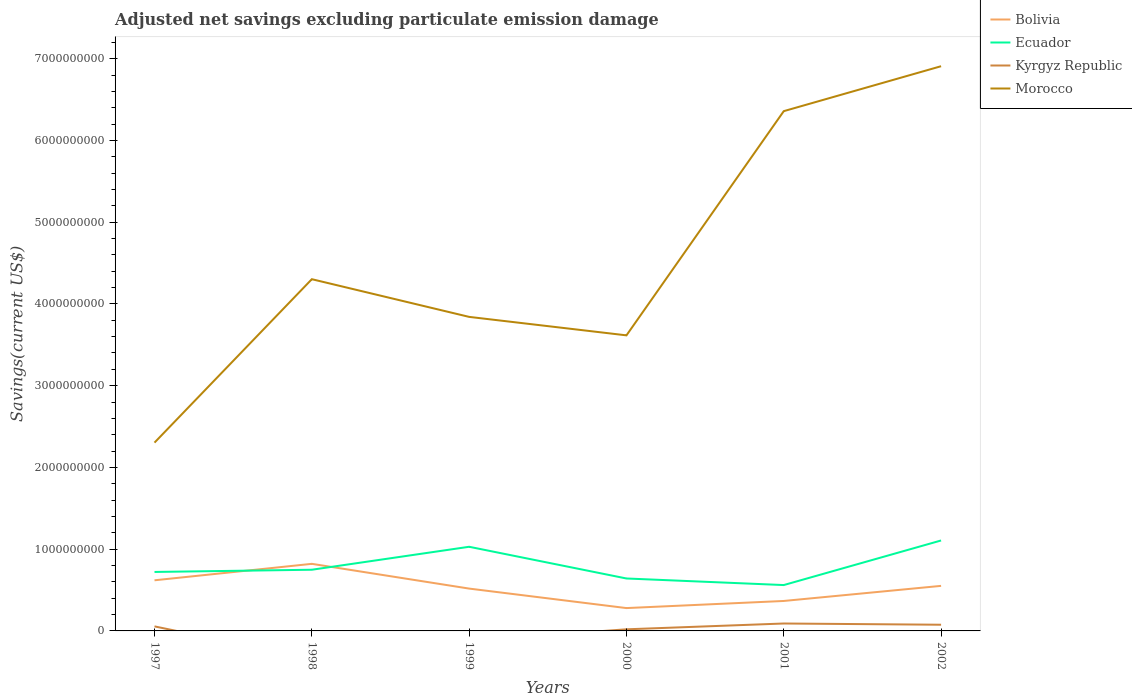Is the number of lines equal to the number of legend labels?
Your answer should be compact. No. Across all years, what is the maximum adjusted net savings in Kyrgyz Republic?
Offer a very short reply. 0. What is the total adjusted net savings in Ecuador in the graph?
Provide a short and direct response. -5.45e+08. What is the difference between the highest and the second highest adjusted net savings in Bolivia?
Offer a terse response. 5.41e+08. How many lines are there?
Provide a succinct answer. 4. How many years are there in the graph?
Provide a short and direct response. 6. What is the difference between two consecutive major ticks on the Y-axis?
Offer a terse response. 1.00e+09. What is the title of the graph?
Your response must be concise. Adjusted net savings excluding particulate emission damage. What is the label or title of the Y-axis?
Give a very brief answer. Savings(current US$). What is the Savings(current US$) in Bolivia in 1997?
Provide a succinct answer. 6.19e+08. What is the Savings(current US$) in Ecuador in 1997?
Your answer should be very brief. 7.21e+08. What is the Savings(current US$) of Kyrgyz Republic in 1997?
Keep it short and to the point. 5.55e+07. What is the Savings(current US$) in Morocco in 1997?
Give a very brief answer. 2.30e+09. What is the Savings(current US$) of Bolivia in 1998?
Your response must be concise. 8.21e+08. What is the Savings(current US$) in Ecuador in 1998?
Give a very brief answer. 7.48e+08. What is the Savings(current US$) of Morocco in 1998?
Provide a short and direct response. 4.30e+09. What is the Savings(current US$) of Bolivia in 1999?
Ensure brevity in your answer.  5.18e+08. What is the Savings(current US$) in Ecuador in 1999?
Ensure brevity in your answer.  1.03e+09. What is the Savings(current US$) of Morocco in 1999?
Your answer should be very brief. 3.84e+09. What is the Savings(current US$) in Bolivia in 2000?
Your answer should be compact. 2.79e+08. What is the Savings(current US$) in Ecuador in 2000?
Make the answer very short. 6.41e+08. What is the Savings(current US$) of Kyrgyz Republic in 2000?
Offer a terse response. 1.97e+07. What is the Savings(current US$) of Morocco in 2000?
Make the answer very short. 3.62e+09. What is the Savings(current US$) in Bolivia in 2001?
Give a very brief answer. 3.66e+08. What is the Savings(current US$) of Ecuador in 2001?
Provide a short and direct response. 5.61e+08. What is the Savings(current US$) in Kyrgyz Republic in 2001?
Provide a succinct answer. 9.07e+07. What is the Savings(current US$) of Morocco in 2001?
Make the answer very short. 6.36e+09. What is the Savings(current US$) in Bolivia in 2002?
Offer a very short reply. 5.51e+08. What is the Savings(current US$) in Ecuador in 2002?
Offer a very short reply. 1.11e+09. What is the Savings(current US$) in Kyrgyz Republic in 2002?
Give a very brief answer. 7.56e+07. What is the Savings(current US$) of Morocco in 2002?
Offer a terse response. 6.91e+09. Across all years, what is the maximum Savings(current US$) in Bolivia?
Your answer should be very brief. 8.21e+08. Across all years, what is the maximum Savings(current US$) of Ecuador?
Offer a very short reply. 1.11e+09. Across all years, what is the maximum Savings(current US$) in Kyrgyz Republic?
Offer a very short reply. 9.07e+07. Across all years, what is the maximum Savings(current US$) of Morocco?
Your response must be concise. 6.91e+09. Across all years, what is the minimum Savings(current US$) of Bolivia?
Your answer should be compact. 2.79e+08. Across all years, what is the minimum Savings(current US$) in Ecuador?
Offer a terse response. 5.61e+08. Across all years, what is the minimum Savings(current US$) in Morocco?
Provide a short and direct response. 2.30e+09. What is the total Savings(current US$) of Bolivia in the graph?
Your answer should be very brief. 3.15e+09. What is the total Savings(current US$) in Ecuador in the graph?
Provide a short and direct response. 4.81e+09. What is the total Savings(current US$) in Kyrgyz Republic in the graph?
Offer a terse response. 2.42e+08. What is the total Savings(current US$) of Morocco in the graph?
Ensure brevity in your answer.  2.73e+1. What is the difference between the Savings(current US$) in Bolivia in 1997 and that in 1998?
Offer a very short reply. -2.01e+08. What is the difference between the Savings(current US$) in Ecuador in 1997 and that in 1998?
Ensure brevity in your answer.  -2.72e+07. What is the difference between the Savings(current US$) of Morocco in 1997 and that in 1998?
Offer a terse response. -2.00e+09. What is the difference between the Savings(current US$) of Bolivia in 1997 and that in 1999?
Ensure brevity in your answer.  1.02e+08. What is the difference between the Savings(current US$) in Ecuador in 1997 and that in 1999?
Your response must be concise. -3.08e+08. What is the difference between the Savings(current US$) of Morocco in 1997 and that in 1999?
Provide a short and direct response. -1.54e+09. What is the difference between the Savings(current US$) in Bolivia in 1997 and that in 2000?
Offer a very short reply. 3.40e+08. What is the difference between the Savings(current US$) in Ecuador in 1997 and that in 2000?
Your answer should be compact. 7.98e+07. What is the difference between the Savings(current US$) of Kyrgyz Republic in 1997 and that in 2000?
Offer a terse response. 3.58e+07. What is the difference between the Savings(current US$) in Morocco in 1997 and that in 2000?
Your answer should be compact. -1.31e+09. What is the difference between the Savings(current US$) of Bolivia in 1997 and that in 2001?
Your response must be concise. 2.53e+08. What is the difference between the Savings(current US$) of Ecuador in 1997 and that in 2001?
Offer a very short reply. 1.60e+08. What is the difference between the Savings(current US$) of Kyrgyz Republic in 1997 and that in 2001?
Provide a succinct answer. -3.52e+07. What is the difference between the Savings(current US$) in Morocco in 1997 and that in 2001?
Offer a terse response. -4.05e+09. What is the difference between the Savings(current US$) in Bolivia in 1997 and that in 2002?
Your answer should be very brief. 6.83e+07. What is the difference between the Savings(current US$) of Ecuador in 1997 and that in 2002?
Ensure brevity in your answer.  -3.85e+08. What is the difference between the Savings(current US$) of Kyrgyz Republic in 1997 and that in 2002?
Your answer should be compact. -2.01e+07. What is the difference between the Savings(current US$) in Morocco in 1997 and that in 2002?
Your answer should be compact. -4.60e+09. What is the difference between the Savings(current US$) of Bolivia in 1998 and that in 1999?
Provide a short and direct response. 3.03e+08. What is the difference between the Savings(current US$) in Ecuador in 1998 and that in 1999?
Your answer should be compact. -2.81e+08. What is the difference between the Savings(current US$) in Morocco in 1998 and that in 1999?
Provide a succinct answer. 4.61e+08. What is the difference between the Savings(current US$) of Bolivia in 1998 and that in 2000?
Offer a terse response. 5.41e+08. What is the difference between the Savings(current US$) of Ecuador in 1998 and that in 2000?
Keep it short and to the point. 1.07e+08. What is the difference between the Savings(current US$) of Morocco in 1998 and that in 2000?
Give a very brief answer. 6.87e+08. What is the difference between the Savings(current US$) of Bolivia in 1998 and that in 2001?
Your answer should be very brief. 4.54e+08. What is the difference between the Savings(current US$) of Ecuador in 1998 and that in 2001?
Offer a terse response. 1.87e+08. What is the difference between the Savings(current US$) in Morocco in 1998 and that in 2001?
Offer a terse response. -2.06e+09. What is the difference between the Savings(current US$) in Bolivia in 1998 and that in 2002?
Keep it short and to the point. 2.70e+08. What is the difference between the Savings(current US$) in Ecuador in 1998 and that in 2002?
Your response must be concise. -3.58e+08. What is the difference between the Savings(current US$) of Morocco in 1998 and that in 2002?
Provide a succinct answer. -2.61e+09. What is the difference between the Savings(current US$) in Bolivia in 1999 and that in 2000?
Your response must be concise. 2.38e+08. What is the difference between the Savings(current US$) of Ecuador in 1999 and that in 2000?
Make the answer very short. 3.88e+08. What is the difference between the Savings(current US$) in Morocco in 1999 and that in 2000?
Keep it short and to the point. 2.26e+08. What is the difference between the Savings(current US$) of Bolivia in 1999 and that in 2001?
Provide a succinct answer. 1.51e+08. What is the difference between the Savings(current US$) of Ecuador in 1999 and that in 2001?
Your answer should be compact. 4.68e+08. What is the difference between the Savings(current US$) in Morocco in 1999 and that in 2001?
Provide a succinct answer. -2.52e+09. What is the difference between the Savings(current US$) in Bolivia in 1999 and that in 2002?
Offer a very short reply. -3.32e+07. What is the difference between the Savings(current US$) of Ecuador in 1999 and that in 2002?
Provide a succinct answer. -7.70e+07. What is the difference between the Savings(current US$) of Morocco in 1999 and that in 2002?
Your answer should be very brief. -3.07e+09. What is the difference between the Savings(current US$) of Bolivia in 2000 and that in 2001?
Provide a succinct answer. -8.71e+07. What is the difference between the Savings(current US$) of Ecuador in 2000 and that in 2001?
Ensure brevity in your answer.  8.04e+07. What is the difference between the Savings(current US$) of Kyrgyz Republic in 2000 and that in 2001?
Your answer should be very brief. -7.10e+07. What is the difference between the Savings(current US$) of Morocco in 2000 and that in 2001?
Give a very brief answer. -2.74e+09. What is the difference between the Savings(current US$) in Bolivia in 2000 and that in 2002?
Ensure brevity in your answer.  -2.72e+08. What is the difference between the Savings(current US$) of Ecuador in 2000 and that in 2002?
Provide a succinct answer. -4.65e+08. What is the difference between the Savings(current US$) of Kyrgyz Republic in 2000 and that in 2002?
Provide a short and direct response. -5.59e+07. What is the difference between the Savings(current US$) in Morocco in 2000 and that in 2002?
Your answer should be very brief. -3.29e+09. What is the difference between the Savings(current US$) in Bolivia in 2001 and that in 2002?
Keep it short and to the point. -1.85e+08. What is the difference between the Savings(current US$) of Ecuador in 2001 and that in 2002?
Your answer should be very brief. -5.45e+08. What is the difference between the Savings(current US$) of Kyrgyz Republic in 2001 and that in 2002?
Keep it short and to the point. 1.51e+07. What is the difference between the Savings(current US$) of Morocco in 2001 and that in 2002?
Provide a short and direct response. -5.50e+08. What is the difference between the Savings(current US$) in Bolivia in 1997 and the Savings(current US$) in Ecuador in 1998?
Keep it short and to the point. -1.29e+08. What is the difference between the Savings(current US$) in Bolivia in 1997 and the Savings(current US$) in Morocco in 1998?
Your response must be concise. -3.68e+09. What is the difference between the Savings(current US$) of Ecuador in 1997 and the Savings(current US$) of Morocco in 1998?
Keep it short and to the point. -3.58e+09. What is the difference between the Savings(current US$) in Kyrgyz Republic in 1997 and the Savings(current US$) in Morocco in 1998?
Give a very brief answer. -4.25e+09. What is the difference between the Savings(current US$) of Bolivia in 1997 and the Savings(current US$) of Ecuador in 1999?
Your answer should be compact. -4.10e+08. What is the difference between the Savings(current US$) of Bolivia in 1997 and the Savings(current US$) of Morocco in 1999?
Provide a succinct answer. -3.22e+09. What is the difference between the Savings(current US$) of Ecuador in 1997 and the Savings(current US$) of Morocco in 1999?
Your response must be concise. -3.12e+09. What is the difference between the Savings(current US$) in Kyrgyz Republic in 1997 and the Savings(current US$) in Morocco in 1999?
Your response must be concise. -3.79e+09. What is the difference between the Savings(current US$) of Bolivia in 1997 and the Savings(current US$) of Ecuador in 2000?
Provide a succinct answer. -2.21e+07. What is the difference between the Savings(current US$) in Bolivia in 1997 and the Savings(current US$) in Kyrgyz Republic in 2000?
Provide a succinct answer. 6.00e+08. What is the difference between the Savings(current US$) in Bolivia in 1997 and the Savings(current US$) in Morocco in 2000?
Give a very brief answer. -3.00e+09. What is the difference between the Savings(current US$) in Ecuador in 1997 and the Savings(current US$) in Kyrgyz Republic in 2000?
Your response must be concise. 7.02e+08. What is the difference between the Savings(current US$) of Ecuador in 1997 and the Savings(current US$) of Morocco in 2000?
Keep it short and to the point. -2.89e+09. What is the difference between the Savings(current US$) of Kyrgyz Republic in 1997 and the Savings(current US$) of Morocco in 2000?
Your answer should be very brief. -3.56e+09. What is the difference between the Savings(current US$) of Bolivia in 1997 and the Savings(current US$) of Ecuador in 2001?
Provide a short and direct response. 5.83e+07. What is the difference between the Savings(current US$) in Bolivia in 1997 and the Savings(current US$) in Kyrgyz Republic in 2001?
Your answer should be very brief. 5.29e+08. What is the difference between the Savings(current US$) of Bolivia in 1997 and the Savings(current US$) of Morocco in 2001?
Offer a very short reply. -5.74e+09. What is the difference between the Savings(current US$) in Ecuador in 1997 and the Savings(current US$) in Kyrgyz Republic in 2001?
Your answer should be very brief. 6.31e+08. What is the difference between the Savings(current US$) in Ecuador in 1997 and the Savings(current US$) in Morocco in 2001?
Your response must be concise. -5.64e+09. What is the difference between the Savings(current US$) of Kyrgyz Republic in 1997 and the Savings(current US$) of Morocco in 2001?
Provide a succinct answer. -6.30e+09. What is the difference between the Savings(current US$) in Bolivia in 1997 and the Savings(current US$) in Ecuador in 2002?
Make the answer very short. -4.87e+08. What is the difference between the Savings(current US$) of Bolivia in 1997 and the Savings(current US$) of Kyrgyz Republic in 2002?
Keep it short and to the point. 5.44e+08. What is the difference between the Savings(current US$) in Bolivia in 1997 and the Savings(current US$) in Morocco in 2002?
Provide a succinct answer. -6.29e+09. What is the difference between the Savings(current US$) of Ecuador in 1997 and the Savings(current US$) of Kyrgyz Republic in 2002?
Offer a terse response. 6.46e+08. What is the difference between the Savings(current US$) of Ecuador in 1997 and the Savings(current US$) of Morocco in 2002?
Your answer should be very brief. -6.19e+09. What is the difference between the Savings(current US$) in Kyrgyz Republic in 1997 and the Savings(current US$) in Morocco in 2002?
Provide a short and direct response. -6.85e+09. What is the difference between the Savings(current US$) in Bolivia in 1998 and the Savings(current US$) in Ecuador in 1999?
Ensure brevity in your answer.  -2.09e+08. What is the difference between the Savings(current US$) in Bolivia in 1998 and the Savings(current US$) in Morocco in 1999?
Offer a terse response. -3.02e+09. What is the difference between the Savings(current US$) in Ecuador in 1998 and the Savings(current US$) in Morocco in 1999?
Your answer should be compact. -3.09e+09. What is the difference between the Savings(current US$) in Bolivia in 1998 and the Savings(current US$) in Ecuador in 2000?
Keep it short and to the point. 1.79e+08. What is the difference between the Savings(current US$) in Bolivia in 1998 and the Savings(current US$) in Kyrgyz Republic in 2000?
Provide a succinct answer. 8.01e+08. What is the difference between the Savings(current US$) of Bolivia in 1998 and the Savings(current US$) of Morocco in 2000?
Provide a short and direct response. -2.80e+09. What is the difference between the Savings(current US$) in Ecuador in 1998 and the Savings(current US$) in Kyrgyz Republic in 2000?
Give a very brief answer. 7.29e+08. What is the difference between the Savings(current US$) in Ecuador in 1998 and the Savings(current US$) in Morocco in 2000?
Your answer should be compact. -2.87e+09. What is the difference between the Savings(current US$) of Bolivia in 1998 and the Savings(current US$) of Ecuador in 2001?
Offer a very short reply. 2.60e+08. What is the difference between the Savings(current US$) of Bolivia in 1998 and the Savings(current US$) of Kyrgyz Republic in 2001?
Your response must be concise. 7.30e+08. What is the difference between the Savings(current US$) in Bolivia in 1998 and the Savings(current US$) in Morocco in 2001?
Your response must be concise. -5.54e+09. What is the difference between the Savings(current US$) of Ecuador in 1998 and the Savings(current US$) of Kyrgyz Republic in 2001?
Ensure brevity in your answer.  6.58e+08. What is the difference between the Savings(current US$) in Ecuador in 1998 and the Savings(current US$) in Morocco in 2001?
Offer a very short reply. -5.61e+09. What is the difference between the Savings(current US$) in Bolivia in 1998 and the Savings(current US$) in Ecuador in 2002?
Offer a very short reply. -2.86e+08. What is the difference between the Savings(current US$) in Bolivia in 1998 and the Savings(current US$) in Kyrgyz Republic in 2002?
Give a very brief answer. 7.45e+08. What is the difference between the Savings(current US$) of Bolivia in 1998 and the Savings(current US$) of Morocco in 2002?
Give a very brief answer. -6.09e+09. What is the difference between the Savings(current US$) of Ecuador in 1998 and the Savings(current US$) of Kyrgyz Republic in 2002?
Your response must be concise. 6.73e+08. What is the difference between the Savings(current US$) of Ecuador in 1998 and the Savings(current US$) of Morocco in 2002?
Provide a short and direct response. -6.16e+09. What is the difference between the Savings(current US$) of Bolivia in 1999 and the Savings(current US$) of Ecuador in 2000?
Your answer should be very brief. -1.24e+08. What is the difference between the Savings(current US$) in Bolivia in 1999 and the Savings(current US$) in Kyrgyz Republic in 2000?
Your response must be concise. 4.98e+08. What is the difference between the Savings(current US$) of Bolivia in 1999 and the Savings(current US$) of Morocco in 2000?
Provide a short and direct response. -3.10e+09. What is the difference between the Savings(current US$) of Ecuador in 1999 and the Savings(current US$) of Kyrgyz Republic in 2000?
Ensure brevity in your answer.  1.01e+09. What is the difference between the Savings(current US$) in Ecuador in 1999 and the Savings(current US$) in Morocco in 2000?
Offer a terse response. -2.59e+09. What is the difference between the Savings(current US$) in Bolivia in 1999 and the Savings(current US$) in Ecuador in 2001?
Ensure brevity in your answer.  -4.32e+07. What is the difference between the Savings(current US$) of Bolivia in 1999 and the Savings(current US$) of Kyrgyz Republic in 2001?
Provide a succinct answer. 4.27e+08. What is the difference between the Savings(current US$) of Bolivia in 1999 and the Savings(current US$) of Morocco in 2001?
Offer a very short reply. -5.84e+09. What is the difference between the Savings(current US$) in Ecuador in 1999 and the Savings(current US$) in Kyrgyz Republic in 2001?
Your answer should be very brief. 9.39e+08. What is the difference between the Savings(current US$) in Ecuador in 1999 and the Savings(current US$) in Morocco in 2001?
Your answer should be very brief. -5.33e+09. What is the difference between the Savings(current US$) of Bolivia in 1999 and the Savings(current US$) of Ecuador in 2002?
Your answer should be compact. -5.89e+08. What is the difference between the Savings(current US$) of Bolivia in 1999 and the Savings(current US$) of Kyrgyz Republic in 2002?
Your answer should be very brief. 4.42e+08. What is the difference between the Savings(current US$) of Bolivia in 1999 and the Savings(current US$) of Morocco in 2002?
Your answer should be compact. -6.39e+09. What is the difference between the Savings(current US$) in Ecuador in 1999 and the Savings(current US$) in Kyrgyz Republic in 2002?
Keep it short and to the point. 9.54e+08. What is the difference between the Savings(current US$) in Ecuador in 1999 and the Savings(current US$) in Morocco in 2002?
Make the answer very short. -5.88e+09. What is the difference between the Savings(current US$) in Bolivia in 2000 and the Savings(current US$) in Ecuador in 2001?
Offer a very short reply. -2.82e+08. What is the difference between the Savings(current US$) in Bolivia in 2000 and the Savings(current US$) in Kyrgyz Republic in 2001?
Keep it short and to the point. 1.89e+08. What is the difference between the Savings(current US$) in Bolivia in 2000 and the Savings(current US$) in Morocco in 2001?
Your answer should be very brief. -6.08e+09. What is the difference between the Savings(current US$) in Ecuador in 2000 and the Savings(current US$) in Kyrgyz Republic in 2001?
Keep it short and to the point. 5.51e+08. What is the difference between the Savings(current US$) in Ecuador in 2000 and the Savings(current US$) in Morocco in 2001?
Your response must be concise. -5.72e+09. What is the difference between the Savings(current US$) in Kyrgyz Republic in 2000 and the Savings(current US$) in Morocco in 2001?
Keep it short and to the point. -6.34e+09. What is the difference between the Savings(current US$) of Bolivia in 2000 and the Savings(current US$) of Ecuador in 2002?
Your response must be concise. -8.27e+08. What is the difference between the Savings(current US$) in Bolivia in 2000 and the Savings(current US$) in Kyrgyz Republic in 2002?
Your answer should be compact. 2.04e+08. What is the difference between the Savings(current US$) of Bolivia in 2000 and the Savings(current US$) of Morocco in 2002?
Make the answer very short. -6.63e+09. What is the difference between the Savings(current US$) in Ecuador in 2000 and the Savings(current US$) in Kyrgyz Republic in 2002?
Your answer should be very brief. 5.66e+08. What is the difference between the Savings(current US$) of Ecuador in 2000 and the Savings(current US$) of Morocco in 2002?
Give a very brief answer. -6.27e+09. What is the difference between the Savings(current US$) in Kyrgyz Republic in 2000 and the Savings(current US$) in Morocco in 2002?
Ensure brevity in your answer.  -6.89e+09. What is the difference between the Savings(current US$) of Bolivia in 2001 and the Savings(current US$) of Ecuador in 2002?
Provide a succinct answer. -7.40e+08. What is the difference between the Savings(current US$) of Bolivia in 2001 and the Savings(current US$) of Kyrgyz Republic in 2002?
Your response must be concise. 2.91e+08. What is the difference between the Savings(current US$) of Bolivia in 2001 and the Savings(current US$) of Morocco in 2002?
Provide a succinct answer. -6.54e+09. What is the difference between the Savings(current US$) in Ecuador in 2001 and the Savings(current US$) in Kyrgyz Republic in 2002?
Offer a terse response. 4.85e+08. What is the difference between the Savings(current US$) of Ecuador in 2001 and the Savings(current US$) of Morocco in 2002?
Ensure brevity in your answer.  -6.35e+09. What is the difference between the Savings(current US$) of Kyrgyz Republic in 2001 and the Savings(current US$) of Morocco in 2002?
Your answer should be very brief. -6.82e+09. What is the average Savings(current US$) in Bolivia per year?
Ensure brevity in your answer.  5.26e+08. What is the average Savings(current US$) of Ecuador per year?
Your response must be concise. 8.01e+08. What is the average Savings(current US$) in Kyrgyz Republic per year?
Your response must be concise. 4.03e+07. What is the average Savings(current US$) in Morocco per year?
Provide a short and direct response. 4.55e+09. In the year 1997, what is the difference between the Savings(current US$) of Bolivia and Savings(current US$) of Ecuador?
Your answer should be compact. -1.02e+08. In the year 1997, what is the difference between the Savings(current US$) of Bolivia and Savings(current US$) of Kyrgyz Republic?
Your answer should be very brief. 5.64e+08. In the year 1997, what is the difference between the Savings(current US$) in Bolivia and Savings(current US$) in Morocco?
Offer a very short reply. -1.68e+09. In the year 1997, what is the difference between the Savings(current US$) of Ecuador and Savings(current US$) of Kyrgyz Republic?
Your response must be concise. 6.66e+08. In the year 1997, what is the difference between the Savings(current US$) of Ecuador and Savings(current US$) of Morocco?
Provide a short and direct response. -1.58e+09. In the year 1997, what is the difference between the Savings(current US$) of Kyrgyz Republic and Savings(current US$) of Morocco?
Your response must be concise. -2.25e+09. In the year 1998, what is the difference between the Savings(current US$) of Bolivia and Savings(current US$) of Ecuador?
Your response must be concise. 7.22e+07. In the year 1998, what is the difference between the Savings(current US$) in Bolivia and Savings(current US$) in Morocco?
Your response must be concise. -3.48e+09. In the year 1998, what is the difference between the Savings(current US$) in Ecuador and Savings(current US$) in Morocco?
Offer a very short reply. -3.55e+09. In the year 1999, what is the difference between the Savings(current US$) in Bolivia and Savings(current US$) in Ecuador?
Your response must be concise. -5.12e+08. In the year 1999, what is the difference between the Savings(current US$) of Bolivia and Savings(current US$) of Morocco?
Provide a succinct answer. -3.32e+09. In the year 1999, what is the difference between the Savings(current US$) of Ecuador and Savings(current US$) of Morocco?
Your answer should be compact. -2.81e+09. In the year 2000, what is the difference between the Savings(current US$) in Bolivia and Savings(current US$) in Ecuador?
Your answer should be compact. -3.62e+08. In the year 2000, what is the difference between the Savings(current US$) in Bolivia and Savings(current US$) in Kyrgyz Republic?
Give a very brief answer. 2.60e+08. In the year 2000, what is the difference between the Savings(current US$) in Bolivia and Savings(current US$) in Morocco?
Make the answer very short. -3.34e+09. In the year 2000, what is the difference between the Savings(current US$) of Ecuador and Savings(current US$) of Kyrgyz Republic?
Offer a very short reply. 6.22e+08. In the year 2000, what is the difference between the Savings(current US$) of Ecuador and Savings(current US$) of Morocco?
Ensure brevity in your answer.  -2.97e+09. In the year 2000, what is the difference between the Savings(current US$) in Kyrgyz Republic and Savings(current US$) in Morocco?
Offer a terse response. -3.60e+09. In the year 2001, what is the difference between the Savings(current US$) in Bolivia and Savings(current US$) in Ecuador?
Offer a very short reply. -1.95e+08. In the year 2001, what is the difference between the Savings(current US$) of Bolivia and Savings(current US$) of Kyrgyz Republic?
Keep it short and to the point. 2.76e+08. In the year 2001, what is the difference between the Savings(current US$) in Bolivia and Savings(current US$) in Morocco?
Make the answer very short. -5.99e+09. In the year 2001, what is the difference between the Savings(current US$) in Ecuador and Savings(current US$) in Kyrgyz Republic?
Offer a terse response. 4.70e+08. In the year 2001, what is the difference between the Savings(current US$) in Ecuador and Savings(current US$) in Morocco?
Your answer should be very brief. -5.80e+09. In the year 2001, what is the difference between the Savings(current US$) of Kyrgyz Republic and Savings(current US$) of Morocco?
Offer a terse response. -6.27e+09. In the year 2002, what is the difference between the Savings(current US$) in Bolivia and Savings(current US$) in Ecuador?
Your answer should be very brief. -5.55e+08. In the year 2002, what is the difference between the Savings(current US$) in Bolivia and Savings(current US$) in Kyrgyz Republic?
Provide a succinct answer. 4.75e+08. In the year 2002, what is the difference between the Savings(current US$) in Bolivia and Savings(current US$) in Morocco?
Keep it short and to the point. -6.36e+09. In the year 2002, what is the difference between the Savings(current US$) in Ecuador and Savings(current US$) in Kyrgyz Republic?
Offer a very short reply. 1.03e+09. In the year 2002, what is the difference between the Savings(current US$) of Ecuador and Savings(current US$) of Morocco?
Offer a very short reply. -5.80e+09. In the year 2002, what is the difference between the Savings(current US$) of Kyrgyz Republic and Savings(current US$) of Morocco?
Offer a terse response. -6.83e+09. What is the ratio of the Savings(current US$) of Bolivia in 1997 to that in 1998?
Ensure brevity in your answer.  0.75. What is the ratio of the Savings(current US$) in Ecuador in 1997 to that in 1998?
Offer a terse response. 0.96. What is the ratio of the Savings(current US$) of Morocco in 1997 to that in 1998?
Your response must be concise. 0.54. What is the ratio of the Savings(current US$) in Bolivia in 1997 to that in 1999?
Offer a terse response. 1.2. What is the ratio of the Savings(current US$) in Ecuador in 1997 to that in 1999?
Provide a short and direct response. 0.7. What is the ratio of the Savings(current US$) in Morocco in 1997 to that in 1999?
Keep it short and to the point. 0.6. What is the ratio of the Savings(current US$) in Bolivia in 1997 to that in 2000?
Your answer should be very brief. 2.22. What is the ratio of the Savings(current US$) of Ecuador in 1997 to that in 2000?
Offer a terse response. 1.12. What is the ratio of the Savings(current US$) in Kyrgyz Republic in 1997 to that in 2000?
Keep it short and to the point. 2.81. What is the ratio of the Savings(current US$) in Morocco in 1997 to that in 2000?
Your answer should be very brief. 0.64. What is the ratio of the Savings(current US$) in Bolivia in 1997 to that in 2001?
Your response must be concise. 1.69. What is the ratio of the Savings(current US$) in Ecuador in 1997 to that in 2001?
Give a very brief answer. 1.29. What is the ratio of the Savings(current US$) of Kyrgyz Republic in 1997 to that in 2001?
Your answer should be very brief. 0.61. What is the ratio of the Savings(current US$) of Morocco in 1997 to that in 2001?
Your answer should be very brief. 0.36. What is the ratio of the Savings(current US$) of Bolivia in 1997 to that in 2002?
Offer a terse response. 1.12. What is the ratio of the Savings(current US$) of Ecuador in 1997 to that in 2002?
Your answer should be compact. 0.65. What is the ratio of the Savings(current US$) in Kyrgyz Republic in 1997 to that in 2002?
Provide a succinct answer. 0.73. What is the ratio of the Savings(current US$) in Morocco in 1997 to that in 2002?
Keep it short and to the point. 0.33. What is the ratio of the Savings(current US$) in Bolivia in 1998 to that in 1999?
Your response must be concise. 1.58. What is the ratio of the Savings(current US$) in Ecuador in 1998 to that in 1999?
Your response must be concise. 0.73. What is the ratio of the Savings(current US$) in Morocco in 1998 to that in 1999?
Offer a terse response. 1.12. What is the ratio of the Savings(current US$) in Bolivia in 1998 to that in 2000?
Provide a succinct answer. 2.94. What is the ratio of the Savings(current US$) of Morocco in 1998 to that in 2000?
Provide a succinct answer. 1.19. What is the ratio of the Savings(current US$) in Bolivia in 1998 to that in 2001?
Provide a short and direct response. 2.24. What is the ratio of the Savings(current US$) in Ecuador in 1998 to that in 2001?
Make the answer very short. 1.33. What is the ratio of the Savings(current US$) in Morocco in 1998 to that in 2001?
Give a very brief answer. 0.68. What is the ratio of the Savings(current US$) of Bolivia in 1998 to that in 2002?
Your answer should be compact. 1.49. What is the ratio of the Savings(current US$) in Ecuador in 1998 to that in 2002?
Keep it short and to the point. 0.68. What is the ratio of the Savings(current US$) in Morocco in 1998 to that in 2002?
Make the answer very short. 0.62. What is the ratio of the Savings(current US$) of Bolivia in 1999 to that in 2000?
Your response must be concise. 1.85. What is the ratio of the Savings(current US$) of Ecuador in 1999 to that in 2000?
Give a very brief answer. 1.6. What is the ratio of the Savings(current US$) of Morocco in 1999 to that in 2000?
Offer a terse response. 1.06. What is the ratio of the Savings(current US$) of Bolivia in 1999 to that in 2001?
Give a very brief answer. 1.41. What is the ratio of the Savings(current US$) in Ecuador in 1999 to that in 2001?
Offer a very short reply. 1.83. What is the ratio of the Savings(current US$) of Morocco in 1999 to that in 2001?
Make the answer very short. 0.6. What is the ratio of the Savings(current US$) in Bolivia in 1999 to that in 2002?
Offer a very short reply. 0.94. What is the ratio of the Savings(current US$) of Ecuador in 1999 to that in 2002?
Your answer should be compact. 0.93. What is the ratio of the Savings(current US$) in Morocco in 1999 to that in 2002?
Provide a succinct answer. 0.56. What is the ratio of the Savings(current US$) of Bolivia in 2000 to that in 2001?
Make the answer very short. 0.76. What is the ratio of the Savings(current US$) in Ecuador in 2000 to that in 2001?
Make the answer very short. 1.14. What is the ratio of the Savings(current US$) in Kyrgyz Republic in 2000 to that in 2001?
Ensure brevity in your answer.  0.22. What is the ratio of the Savings(current US$) in Morocco in 2000 to that in 2001?
Ensure brevity in your answer.  0.57. What is the ratio of the Savings(current US$) of Bolivia in 2000 to that in 2002?
Ensure brevity in your answer.  0.51. What is the ratio of the Savings(current US$) in Ecuador in 2000 to that in 2002?
Ensure brevity in your answer.  0.58. What is the ratio of the Savings(current US$) in Kyrgyz Republic in 2000 to that in 2002?
Give a very brief answer. 0.26. What is the ratio of the Savings(current US$) of Morocco in 2000 to that in 2002?
Ensure brevity in your answer.  0.52. What is the ratio of the Savings(current US$) in Bolivia in 2001 to that in 2002?
Provide a short and direct response. 0.67. What is the ratio of the Savings(current US$) in Ecuador in 2001 to that in 2002?
Make the answer very short. 0.51. What is the ratio of the Savings(current US$) in Kyrgyz Republic in 2001 to that in 2002?
Provide a short and direct response. 1.2. What is the ratio of the Savings(current US$) of Morocco in 2001 to that in 2002?
Offer a very short reply. 0.92. What is the difference between the highest and the second highest Savings(current US$) of Bolivia?
Your answer should be compact. 2.01e+08. What is the difference between the highest and the second highest Savings(current US$) in Ecuador?
Give a very brief answer. 7.70e+07. What is the difference between the highest and the second highest Savings(current US$) in Kyrgyz Republic?
Give a very brief answer. 1.51e+07. What is the difference between the highest and the second highest Savings(current US$) of Morocco?
Your answer should be very brief. 5.50e+08. What is the difference between the highest and the lowest Savings(current US$) in Bolivia?
Your response must be concise. 5.41e+08. What is the difference between the highest and the lowest Savings(current US$) of Ecuador?
Ensure brevity in your answer.  5.45e+08. What is the difference between the highest and the lowest Savings(current US$) in Kyrgyz Republic?
Offer a very short reply. 9.07e+07. What is the difference between the highest and the lowest Savings(current US$) in Morocco?
Your response must be concise. 4.60e+09. 